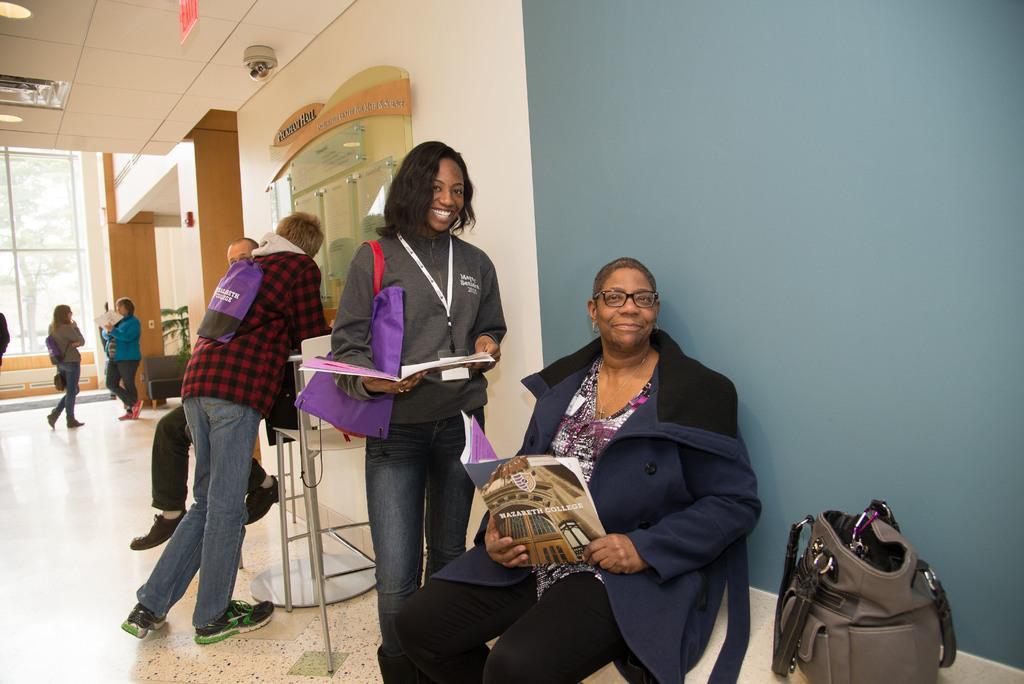Describe this image in one or two sentences. In this image I can see the floor, few persons standing on the floor, a person sitting, a bag beside her and I can see few of them are holding books in their hands. In the background I can see the cream colored wall, the ceiling, few lights to the ceiling, the window and through the window I can see few trees. 